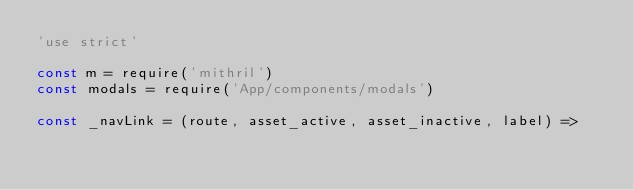Convert code to text. <code><loc_0><loc_0><loc_500><loc_500><_JavaScript_>'use strict'

const m = require('mithril')
const modals = require('App/components/modals')

const _navLink = (route, asset_active, asset_inactive, label) =></code> 